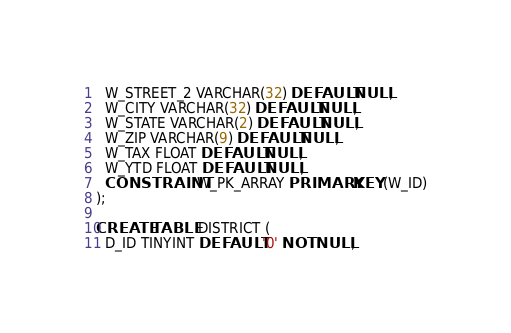Convert code to text. <code><loc_0><loc_0><loc_500><loc_500><_SQL_>  W_STREET_2 VARCHAR(32) DEFAULT NULL,
  W_CITY VARCHAR(32) DEFAULT NULL,
  W_STATE VARCHAR(2) DEFAULT NULL,
  W_ZIP VARCHAR(9) DEFAULT NULL,
  W_TAX FLOAT DEFAULT NULL,
  W_YTD FLOAT DEFAULT NULL,
  CONSTRAINT W_PK_ARRAY PRIMARY KEY (W_ID)
);

CREATE TABLE DISTRICT (
  D_ID TINYINT DEFAULT '0' NOT NULL,</code> 